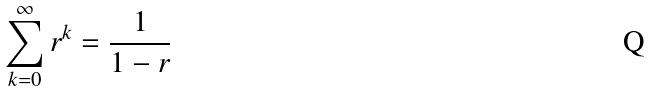Convert formula to latex. <formula><loc_0><loc_0><loc_500><loc_500>\sum _ { k = 0 } ^ { \infty } r ^ { k } = \frac { 1 } { 1 - r }</formula> 